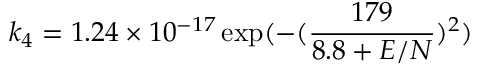<formula> <loc_0><loc_0><loc_500><loc_500>k _ { 4 } = 1 . 2 4 \times 1 0 ^ { - 1 7 } \exp ( - ( \frac { 1 7 9 } { 8 . 8 + E / N } ) ^ { 2 } )</formula> 